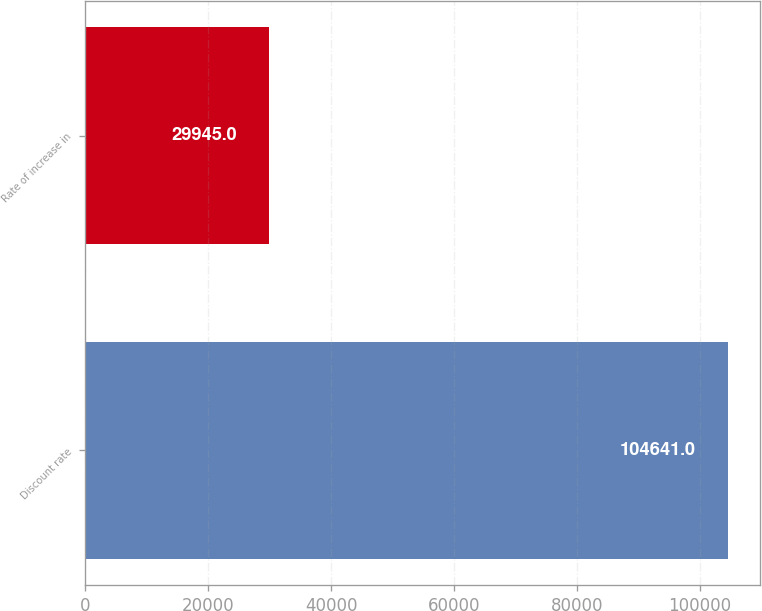<chart> <loc_0><loc_0><loc_500><loc_500><bar_chart><fcel>Discount rate<fcel>Rate of increase in<nl><fcel>104641<fcel>29945<nl></chart> 